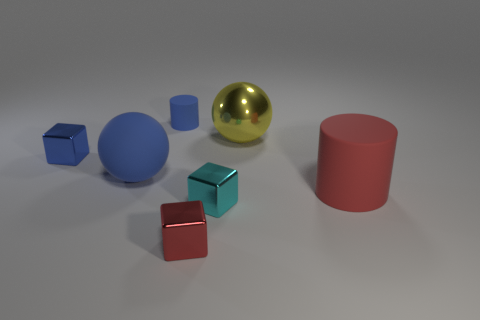What is the color of the block behind the big cylinder?
Provide a short and direct response. Blue. What is the size of the sphere that is the same material as the big red cylinder?
Offer a terse response. Large. The cyan object that is the same shape as the small blue metallic object is what size?
Ensure brevity in your answer.  Small. Is there a sphere?
Offer a very short reply. Yes. How many things are red things that are in front of the big red matte cylinder or small rubber blocks?
Make the answer very short. 1. What material is the cylinder that is the same size as the cyan object?
Give a very brief answer. Rubber. What is the color of the tiny block that is behind the cylinder that is to the right of the tiny rubber object?
Provide a succinct answer. Blue. There is a large yellow ball; what number of red metal cubes are on the right side of it?
Provide a succinct answer. 0. What is the color of the large shiny sphere?
Offer a very short reply. Yellow. What number of large objects are cylinders or yellow balls?
Offer a terse response. 2. 